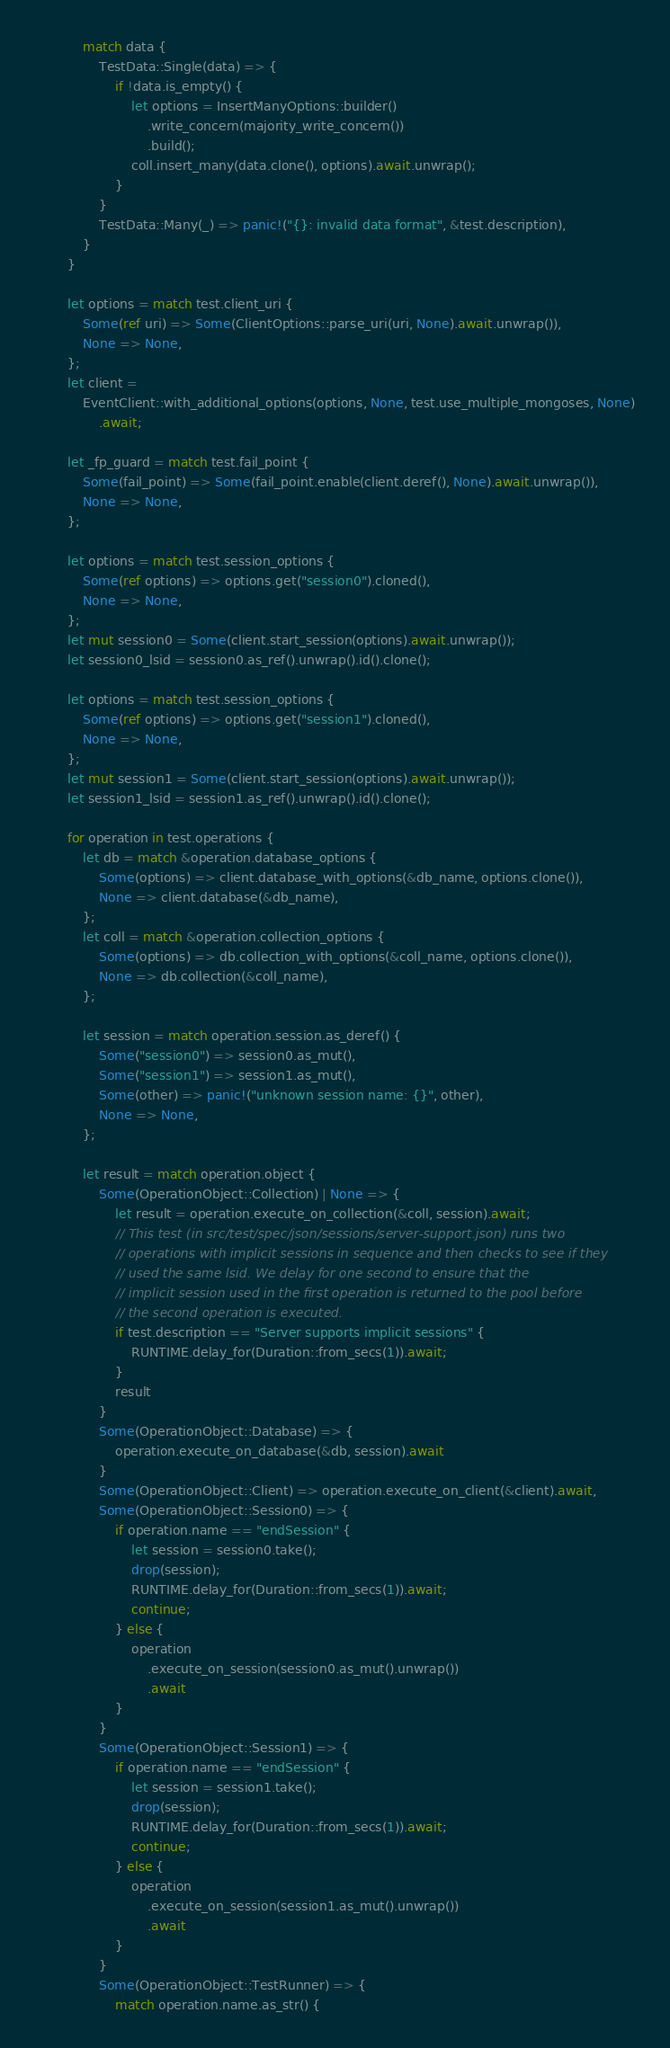<code> <loc_0><loc_0><loc_500><loc_500><_Rust_>            match data {
                TestData::Single(data) => {
                    if !data.is_empty() {
                        let options = InsertManyOptions::builder()
                            .write_concern(majority_write_concern())
                            .build();
                        coll.insert_many(data.clone(), options).await.unwrap();
                    }
                }
                TestData::Many(_) => panic!("{}: invalid data format", &test.description),
            }
        }

        let options = match test.client_uri {
            Some(ref uri) => Some(ClientOptions::parse_uri(uri, None).await.unwrap()),
            None => None,
        };
        let client =
            EventClient::with_additional_options(options, None, test.use_multiple_mongoses, None)
                .await;

        let _fp_guard = match test.fail_point {
            Some(fail_point) => Some(fail_point.enable(client.deref(), None).await.unwrap()),
            None => None,
        };

        let options = match test.session_options {
            Some(ref options) => options.get("session0").cloned(),
            None => None,
        };
        let mut session0 = Some(client.start_session(options).await.unwrap());
        let session0_lsid = session0.as_ref().unwrap().id().clone();

        let options = match test.session_options {
            Some(ref options) => options.get("session1").cloned(),
            None => None,
        };
        let mut session1 = Some(client.start_session(options).await.unwrap());
        let session1_lsid = session1.as_ref().unwrap().id().clone();

        for operation in test.operations {
            let db = match &operation.database_options {
                Some(options) => client.database_with_options(&db_name, options.clone()),
                None => client.database(&db_name),
            };
            let coll = match &operation.collection_options {
                Some(options) => db.collection_with_options(&coll_name, options.clone()),
                None => db.collection(&coll_name),
            };

            let session = match operation.session.as_deref() {
                Some("session0") => session0.as_mut(),
                Some("session1") => session1.as_mut(),
                Some(other) => panic!("unknown session name: {}", other),
                None => None,
            };

            let result = match operation.object {
                Some(OperationObject::Collection) | None => {
                    let result = operation.execute_on_collection(&coll, session).await;
                    // This test (in src/test/spec/json/sessions/server-support.json) runs two
                    // operations with implicit sessions in sequence and then checks to see if they
                    // used the same lsid. We delay for one second to ensure that the
                    // implicit session used in the first operation is returned to the pool before
                    // the second operation is executed.
                    if test.description == "Server supports implicit sessions" {
                        RUNTIME.delay_for(Duration::from_secs(1)).await;
                    }
                    result
                }
                Some(OperationObject::Database) => {
                    operation.execute_on_database(&db, session).await
                }
                Some(OperationObject::Client) => operation.execute_on_client(&client).await,
                Some(OperationObject::Session0) => {
                    if operation.name == "endSession" {
                        let session = session0.take();
                        drop(session);
                        RUNTIME.delay_for(Duration::from_secs(1)).await;
                        continue;
                    } else {
                        operation
                            .execute_on_session(session0.as_mut().unwrap())
                            .await
                    }
                }
                Some(OperationObject::Session1) => {
                    if operation.name == "endSession" {
                        let session = session1.take();
                        drop(session);
                        RUNTIME.delay_for(Duration::from_secs(1)).await;
                        continue;
                    } else {
                        operation
                            .execute_on_session(session1.as_mut().unwrap())
                            .await
                    }
                }
                Some(OperationObject::TestRunner) => {
                    match operation.name.as_str() {</code> 